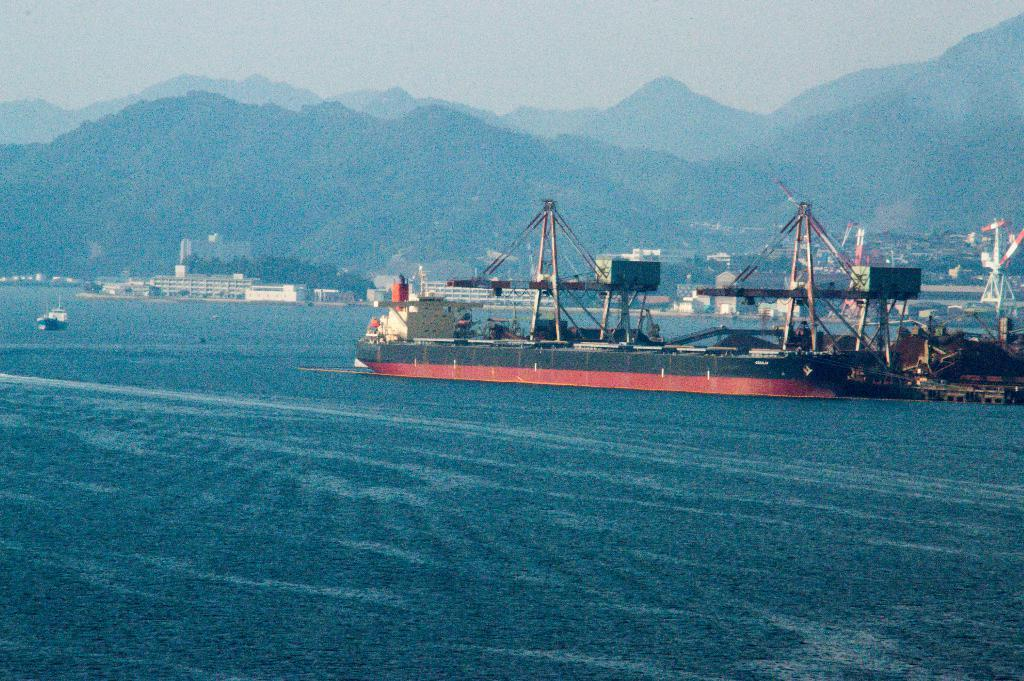What is present on the river in the image? There are ships on the river in the image. What can be seen in the distance behind the river? There are buildings, trees, mountains, and the sky visible in the background of the image. Where is the cart located in the image? There is no cart present in the image. What type of town can be seen in the image? The image does not depict a town; it shows a river with ships and a background with buildings, trees, mountains, and the sky. 